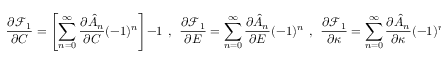Convert formula to latex. <formula><loc_0><loc_0><loc_500><loc_500>\frac { \partial \mathcal { F } _ { 1 } } { \partial C } = \left [ \sum _ { n = 0 } ^ { \infty } \frac { \partial \hat { A } _ { n } } { \partial C } ( - 1 ) ^ { n } \right ] - 1 , \frac { \partial \mathcal { F } _ { 1 } } { \partial E } = \sum _ { n = 0 } ^ { \infty } \frac { \partial \hat { A } _ { n } } { \partial E } ( - 1 ) ^ { n } , \frac { \partial \mathcal { F } _ { 1 } } { \partial \kappa } = \sum _ { n = 0 } ^ { \infty } \frac { \partial \hat { A } _ { n } } { \partial \kappa } ( - 1 ) ^ { n } ,</formula> 